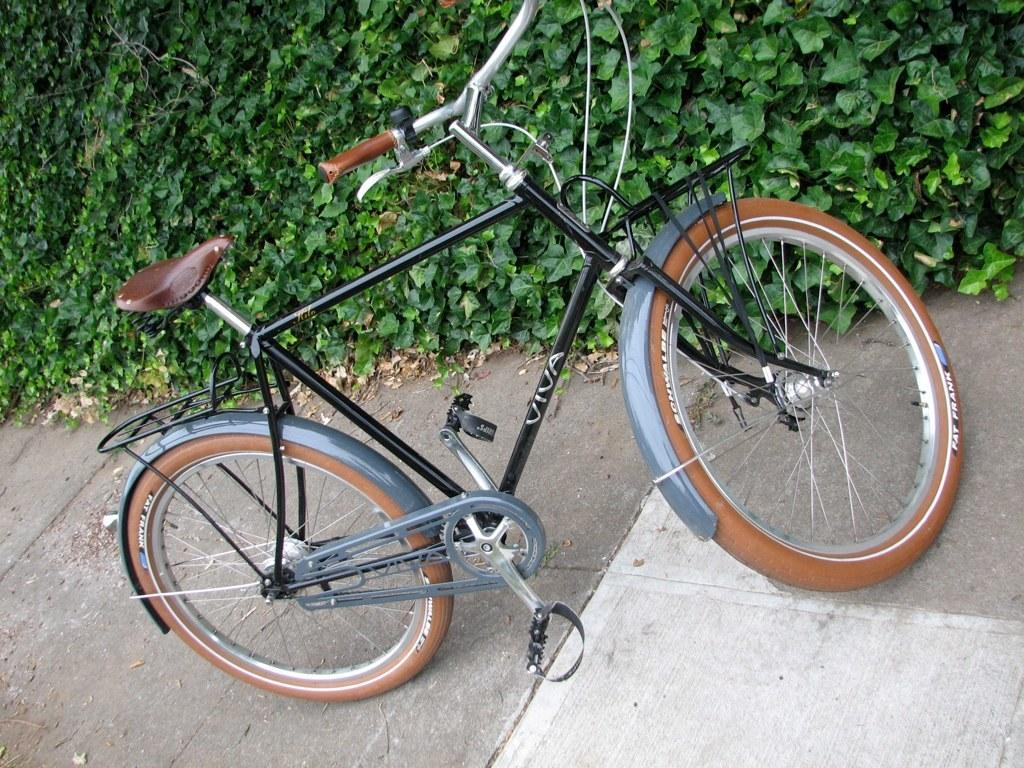What is the main subject of the image? The main subject of the image is a bicycle. What colors can be seen on the bicycle? The bicycle is brown, black, and ash in color. What can be seen in the background of the image? There are trees visible in the background. Where is the bicycle located in the image? The bicycle is on the road. What type of meat is being cooked on the bicycle in the image? There is no meat or cooking activity present in the image; it features a bicycle on the road with trees in the background. 